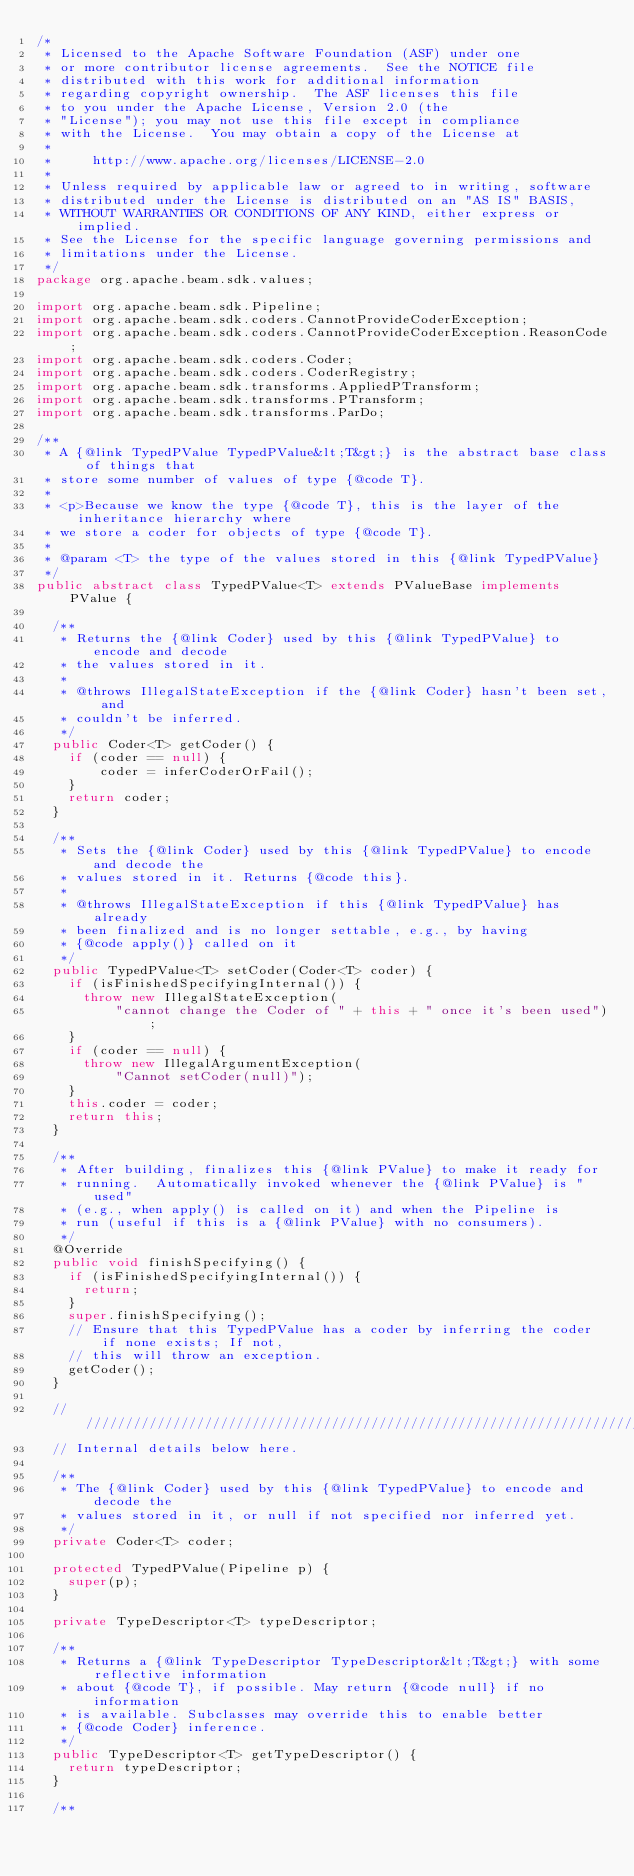<code> <loc_0><loc_0><loc_500><loc_500><_Java_>/*
 * Licensed to the Apache Software Foundation (ASF) under one
 * or more contributor license agreements.  See the NOTICE file
 * distributed with this work for additional information
 * regarding copyright ownership.  The ASF licenses this file
 * to you under the Apache License, Version 2.0 (the
 * "License"); you may not use this file except in compliance
 * with the License.  You may obtain a copy of the License at
 *
 *     http://www.apache.org/licenses/LICENSE-2.0
 *
 * Unless required by applicable law or agreed to in writing, software
 * distributed under the License is distributed on an "AS IS" BASIS,
 * WITHOUT WARRANTIES OR CONDITIONS OF ANY KIND, either express or implied.
 * See the License for the specific language governing permissions and
 * limitations under the License.
 */
package org.apache.beam.sdk.values;

import org.apache.beam.sdk.Pipeline;
import org.apache.beam.sdk.coders.CannotProvideCoderException;
import org.apache.beam.sdk.coders.CannotProvideCoderException.ReasonCode;
import org.apache.beam.sdk.coders.Coder;
import org.apache.beam.sdk.coders.CoderRegistry;
import org.apache.beam.sdk.transforms.AppliedPTransform;
import org.apache.beam.sdk.transforms.PTransform;
import org.apache.beam.sdk.transforms.ParDo;

/**
 * A {@link TypedPValue TypedPValue&lt;T&gt;} is the abstract base class of things that
 * store some number of values of type {@code T}.
 *
 * <p>Because we know the type {@code T}, this is the layer of the inheritance hierarchy where
 * we store a coder for objects of type {@code T}.
 *
 * @param <T> the type of the values stored in this {@link TypedPValue}
 */
public abstract class TypedPValue<T> extends PValueBase implements PValue {

  /**
   * Returns the {@link Coder} used by this {@link TypedPValue} to encode and decode
   * the values stored in it.
   *
   * @throws IllegalStateException if the {@link Coder} hasn't been set, and
   * couldn't be inferred.
   */
  public Coder<T> getCoder() {
    if (coder == null) {
        coder = inferCoderOrFail();
    }
    return coder;
  }

  /**
   * Sets the {@link Coder} used by this {@link TypedPValue} to encode and decode the
   * values stored in it. Returns {@code this}.
   *
   * @throws IllegalStateException if this {@link TypedPValue} has already
   * been finalized and is no longer settable, e.g., by having
   * {@code apply()} called on it
   */
  public TypedPValue<T> setCoder(Coder<T> coder) {
    if (isFinishedSpecifyingInternal()) {
      throw new IllegalStateException(
          "cannot change the Coder of " + this + " once it's been used");
    }
    if (coder == null) {
      throw new IllegalArgumentException(
          "Cannot setCoder(null)");
    }
    this.coder = coder;
    return this;
  }

  /**
   * After building, finalizes this {@link PValue} to make it ready for
   * running.  Automatically invoked whenever the {@link PValue} is "used"
   * (e.g., when apply() is called on it) and when the Pipeline is
   * run (useful if this is a {@link PValue} with no consumers).
   */
  @Override
  public void finishSpecifying() {
    if (isFinishedSpecifyingInternal()) {
      return;
    }
    super.finishSpecifying();
    // Ensure that this TypedPValue has a coder by inferring the coder if none exists; If not,
    // this will throw an exception.
    getCoder();
  }

  /////////////////////////////////////////////////////////////////////////////
  // Internal details below here.

  /**
   * The {@link Coder} used by this {@link TypedPValue} to encode and decode the
   * values stored in it, or null if not specified nor inferred yet.
   */
  private Coder<T> coder;

  protected TypedPValue(Pipeline p) {
    super(p);
  }

  private TypeDescriptor<T> typeDescriptor;

  /**
   * Returns a {@link TypeDescriptor TypeDescriptor&lt;T&gt;} with some reflective information
   * about {@code T}, if possible. May return {@code null} if no information
   * is available. Subclasses may override this to enable better
   * {@code Coder} inference.
   */
  public TypeDescriptor<T> getTypeDescriptor() {
    return typeDescriptor;
  }

  /**</code> 